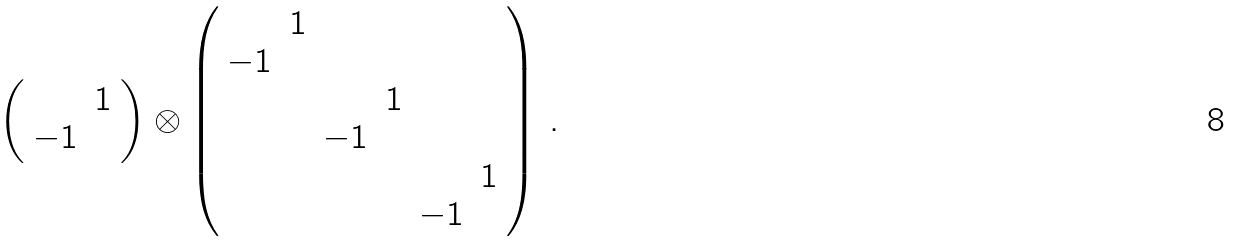<formula> <loc_0><loc_0><loc_500><loc_500>\left ( \begin{array} { c c } & 1 \\ - 1 & \end{array} \right ) \otimes \left ( \begin{array} { c c c c c c } & 1 & & & & \\ - 1 & & & & & \\ & & & 1 & & \\ & & - 1 & & & \\ & & & & & 1 \\ & & & & - 1 & \end{array} \right ) \, .</formula> 